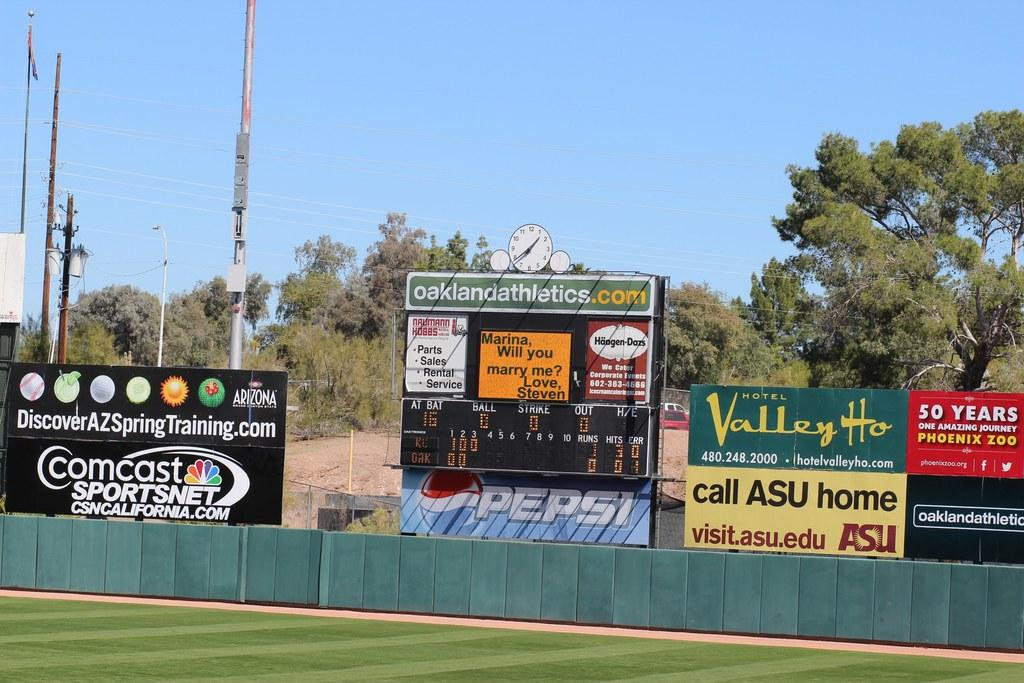Provide a one-sentence caption for the provided image. Baseball field that is being televised by Comcast Sportsnet. 